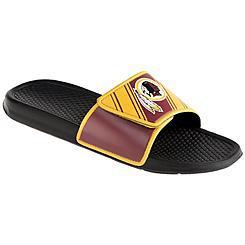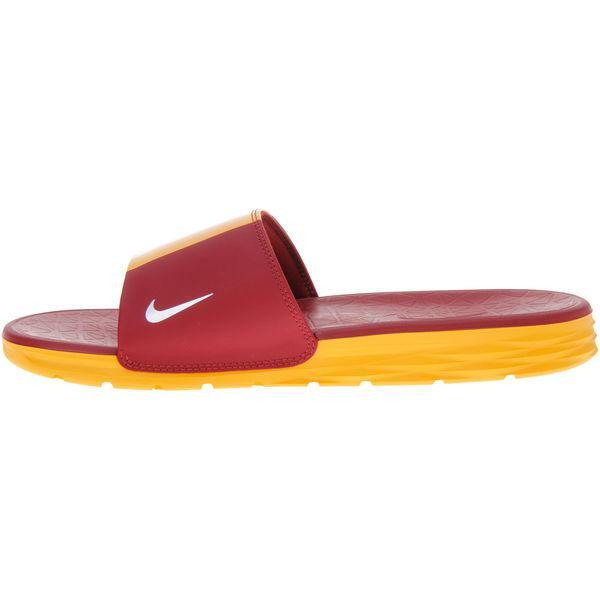The first image is the image on the left, the second image is the image on the right. For the images displayed, is the sentence "A tan pair of moccasins in one image has a sports logo on each one that is the same logo seen on a red and yellow slipper in the other image." factually correct? Answer yes or no. No. The first image is the image on the left, the second image is the image on the right. Given the left and right images, does the statement "Each footwear item features a sillhouette of an Indian warrior, and the left image contains one yellow and burgundy slipper, while the right image contains a pair of moccasins." hold true? Answer yes or no. No. 